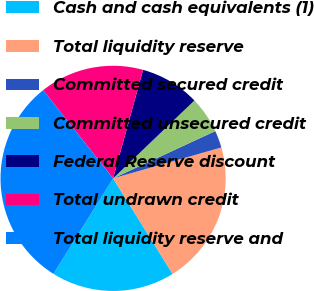Convert chart to OTSL. <chart><loc_0><loc_0><loc_500><loc_500><pie_chart><fcel>Cash and cash equivalents (1)<fcel>Total liquidity reserve<fcel>Committed secured credit<fcel>Committed unsecured credit<fcel>Federal Reserve discount<fcel>Total undrawn credit<fcel>Total liquidity reserve and<nl><fcel>17.76%<fcel>20.56%<fcel>2.47%<fcel>5.26%<fcel>8.55%<fcel>14.97%<fcel>30.43%<nl></chart> 